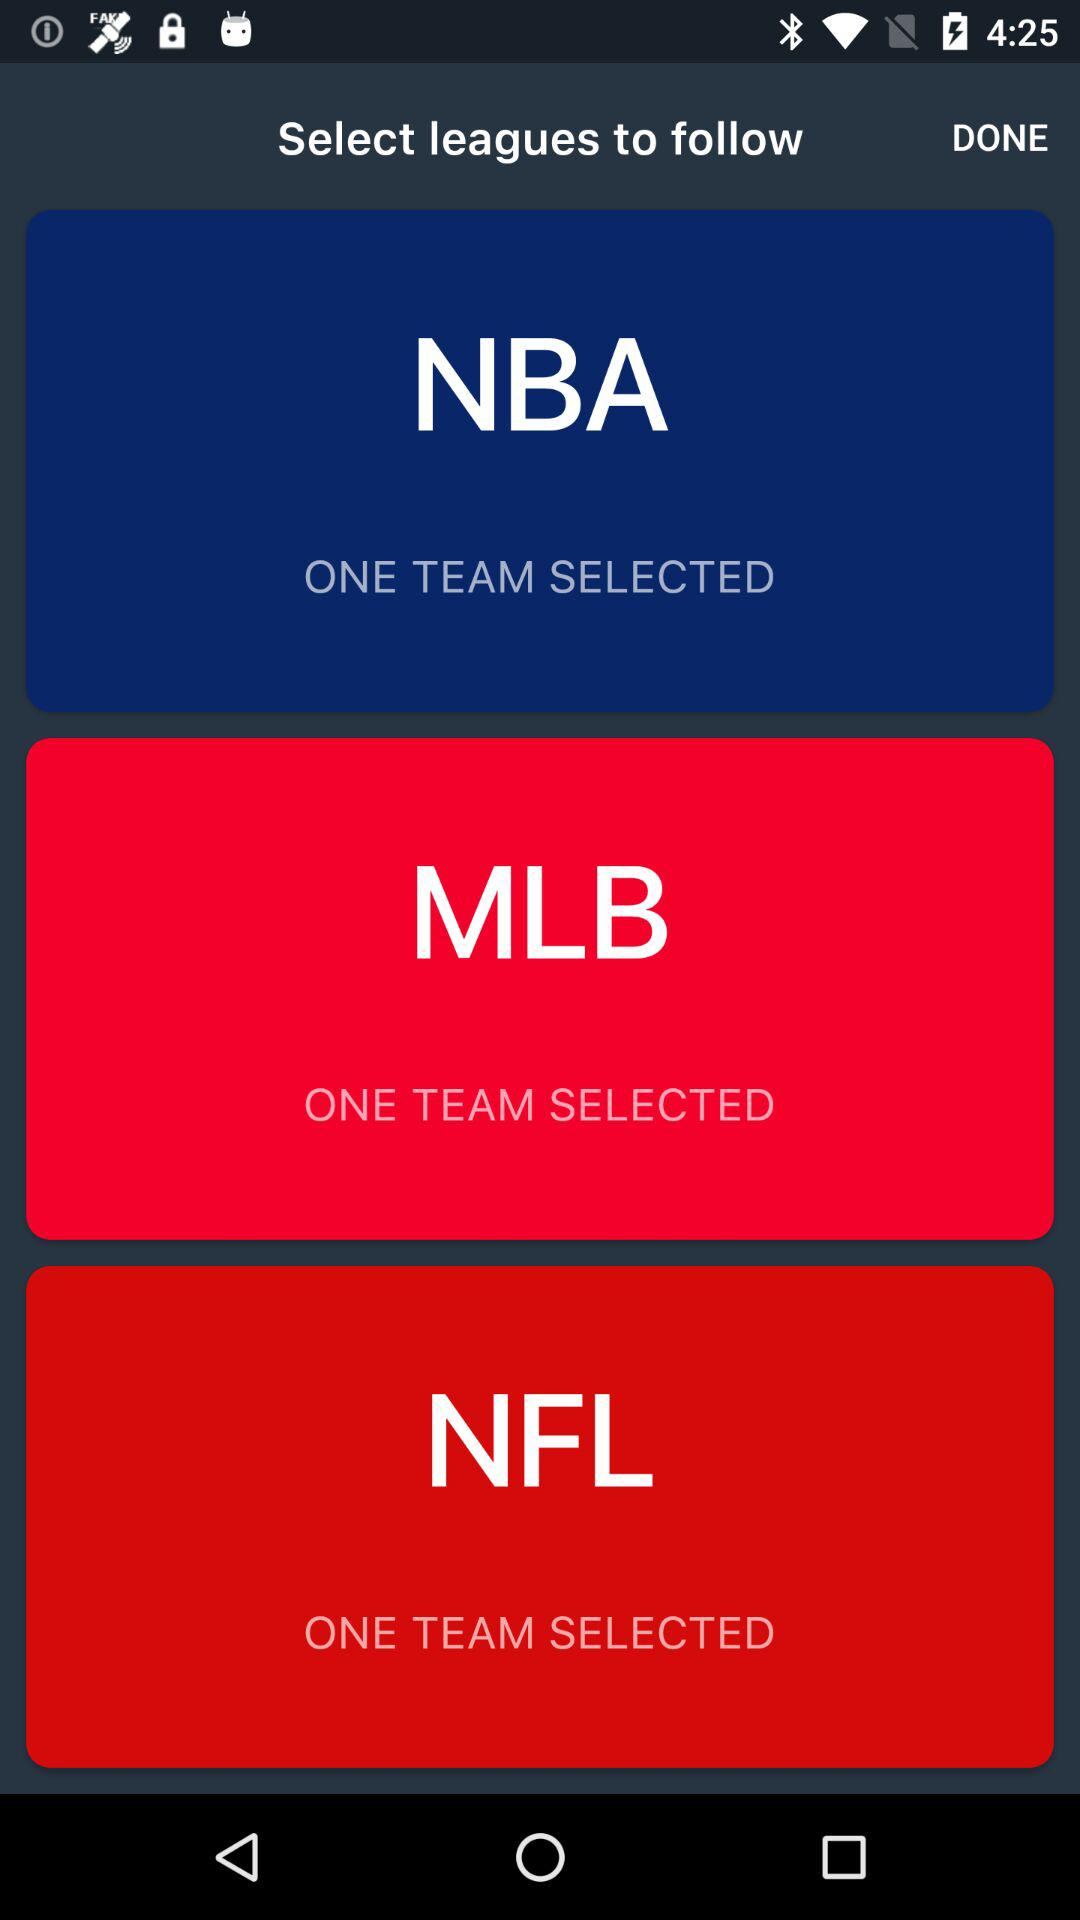How many teams have been selected in total?
Answer the question using a single word or phrase. 3 